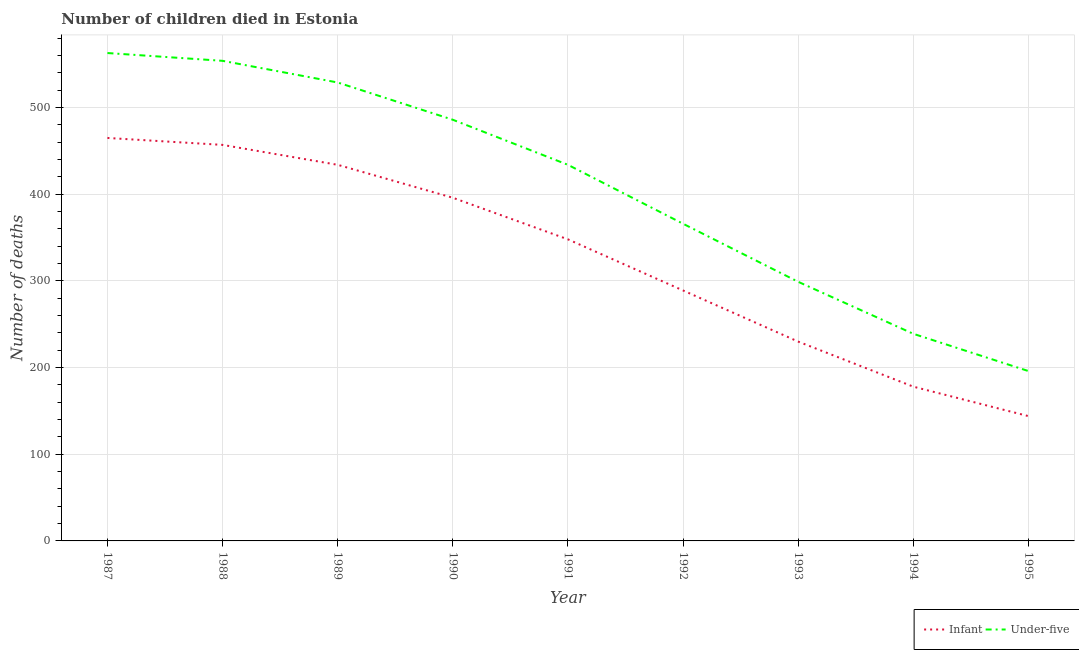Does the line corresponding to number of under-five deaths intersect with the line corresponding to number of infant deaths?
Give a very brief answer. No. What is the number of under-five deaths in 1994?
Provide a short and direct response. 239. Across all years, what is the maximum number of infant deaths?
Provide a succinct answer. 465. Across all years, what is the minimum number of under-five deaths?
Your answer should be compact. 196. In which year was the number of infant deaths minimum?
Provide a succinct answer. 1995. What is the total number of under-five deaths in the graph?
Your response must be concise. 3666. What is the difference between the number of infant deaths in 1990 and that in 1991?
Keep it short and to the point. 48. What is the difference between the number of under-five deaths in 1992 and the number of infant deaths in 1990?
Offer a terse response. -30. What is the average number of infant deaths per year?
Provide a short and direct response. 326.78. In the year 1989, what is the difference between the number of infant deaths and number of under-five deaths?
Your answer should be very brief. -95. In how many years, is the number of infant deaths greater than 200?
Your answer should be compact. 7. What is the ratio of the number of infant deaths in 1993 to that in 1994?
Your answer should be compact. 1.29. Is the number of infant deaths in 1990 less than that in 1991?
Offer a very short reply. No. Is the difference between the number of under-five deaths in 1992 and 1995 greater than the difference between the number of infant deaths in 1992 and 1995?
Ensure brevity in your answer.  Yes. What is the difference between the highest and the second highest number of under-five deaths?
Offer a very short reply. 9. What is the difference between the highest and the lowest number of infant deaths?
Make the answer very short. 321. In how many years, is the number of under-five deaths greater than the average number of under-five deaths taken over all years?
Make the answer very short. 5. Does the number of infant deaths monotonically increase over the years?
Keep it short and to the point. No. How many years are there in the graph?
Your answer should be compact. 9. What is the difference between two consecutive major ticks on the Y-axis?
Make the answer very short. 100. Does the graph contain grids?
Offer a terse response. Yes. Where does the legend appear in the graph?
Your answer should be compact. Bottom right. What is the title of the graph?
Provide a short and direct response. Number of children died in Estonia. What is the label or title of the X-axis?
Ensure brevity in your answer.  Year. What is the label or title of the Y-axis?
Your response must be concise. Number of deaths. What is the Number of deaths of Infant in 1987?
Ensure brevity in your answer.  465. What is the Number of deaths of Under-five in 1987?
Offer a very short reply. 563. What is the Number of deaths of Infant in 1988?
Provide a succinct answer. 457. What is the Number of deaths of Under-five in 1988?
Offer a very short reply. 554. What is the Number of deaths of Infant in 1989?
Give a very brief answer. 434. What is the Number of deaths of Under-five in 1989?
Make the answer very short. 529. What is the Number of deaths of Infant in 1990?
Your answer should be very brief. 396. What is the Number of deaths of Under-five in 1990?
Your response must be concise. 486. What is the Number of deaths of Infant in 1991?
Provide a short and direct response. 348. What is the Number of deaths of Under-five in 1991?
Make the answer very short. 434. What is the Number of deaths of Infant in 1992?
Offer a terse response. 289. What is the Number of deaths in Under-five in 1992?
Your response must be concise. 366. What is the Number of deaths in Infant in 1993?
Provide a short and direct response. 230. What is the Number of deaths of Under-five in 1993?
Your answer should be very brief. 299. What is the Number of deaths in Infant in 1994?
Give a very brief answer. 178. What is the Number of deaths in Under-five in 1994?
Your answer should be compact. 239. What is the Number of deaths of Infant in 1995?
Keep it short and to the point. 144. What is the Number of deaths of Under-five in 1995?
Offer a terse response. 196. Across all years, what is the maximum Number of deaths in Infant?
Your answer should be compact. 465. Across all years, what is the maximum Number of deaths in Under-five?
Provide a succinct answer. 563. Across all years, what is the minimum Number of deaths of Infant?
Provide a short and direct response. 144. Across all years, what is the minimum Number of deaths of Under-five?
Make the answer very short. 196. What is the total Number of deaths of Infant in the graph?
Your response must be concise. 2941. What is the total Number of deaths of Under-five in the graph?
Provide a succinct answer. 3666. What is the difference between the Number of deaths of Under-five in 1987 and that in 1988?
Offer a very short reply. 9. What is the difference between the Number of deaths of Under-five in 1987 and that in 1989?
Make the answer very short. 34. What is the difference between the Number of deaths in Under-five in 1987 and that in 1990?
Your answer should be very brief. 77. What is the difference between the Number of deaths of Infant in 1987 and that in 1991?
Keep it short and to the point. 117. What is the difference between the Number of deaths of Under-five in 1987 and that in 1991?
Make the answer very short. 129. What is the difference between the Number of deaths of Infant in 1987 and that in 1992?
Provide a succinct answer. 176. What is the difference between the Number of deaths of Under-five in 1987 and that in 1992?
Your answer should be very brief. 197. What is the difference between the Number of deaths in Infant in 1987 and that in 1993?
Offer a terse response. 235. What is the difference between the Number of deaths of Under-five in 1987 and that in 1993?
Your response must be concise. 264. What is the difference between the Number of deaths of Infant in 1987 and that in 1994?
Keep it short and to the point. 287. What is the difference between the Number of deaths in Under-five in 1987 and that in 1994?
Give a very brief answer. 324. What is the difference between the Number of deaths in Infant in 1987 and that in 1995?
Keep it short and to the point. 321. What is the difference between the Number of deaths of Under-five in 1987 and that in 1995?
Offer a very short reply. 367. What is the difference between the Number of deaths of Infant in 1988 and that in 1989?
Provide a short and direct response. 23. What is the difference between the Number of deaths in Infant in 1988 and that in 1990?
Your answer should be very brief. 61. What is the difference between the Number of deaths of Infant in 1988 and that in 1991?
Provide a short and direct response. 109. What is the difference between the Number of deaths in Under-five in 1988 and that in 1991?
Provide a short and direct response. 120. What is the difference between the Number of deaths in Infant in 1988 and that in 1992?
Make the answer very short. 168. What is the difference between the Number of deaths of Under-five in 1988 and that in 1992?
Make the answer very short. 188. What is the difference between the Number of deaths in Infant in 1988 and that in 1993?
Provide a succinct answer. 227. What is the difference between the Number of deaths of Under-five in 1988 and that in 1993?
Give a very brief answer. 255. What is the difference between the Number of deaths in Infant in 1988 and that in 1994?
Offer a very short reply. 279. What is the difference between the Number of deaths of Under-five in 1988 and that in 1994?
Offer a terse response. 315. What is the difference between the Number of deaths of Infant in 1988 and that in 1995?
Make the answer very short. 313. What is the difference between the Number of deaths of Under-five in 1988 and that in 1995?
Offer a terse response. 358. What is the difference between the Number of deaths of Under-five in 1989 and that in 1991?
Offer a terse response. 95. What is the difference between the Number of deaths of Infant in 1989 and that in 1992?
Offer a terse response. 145. What is the difference between the Number of deaths in Under-five in 1989 and that in 1992?
Keep it short and to the point. 163. What is the difference between the Number of deaths of Infant in 1989 and that in 1993?
Offer a terse response. 204. What is the difference between the Number of deaths of Under-five in 1989 and that in 1993?
Give a very brief answer. 230. What is the difference between the Number of deaths in Infant in 1989 and that in 1994?
Offer a very short reply. 256. What is the difference between the Number of deaths of Under-five in 1989 and that in 1994?
Your answer should be very brief. 290. What is the difference between the Number of deaths in Infant in 1989 and that in 1995?
Give a very brief answer. 290. What is the difference between the Number of deaths in Under-five in 1989 and that in 1995?
Your response must be concise. 333. What is the difference between the Number of deaths of Infant in 1990 and that in 1991?
Offer a terse response. 48. What is the difference between the Number of deaths in Infant in 1990 and that in 1992?
Provide a short and direct response. 107. What is the difference between the Number of deaths in Under-five in 1990 and that in 1992?
Offer a very short reply. 120. What is the difference between the Number of deaths of Infant in 1990 and that in 1993?
Offer a terse response. 166. What is the difference between the Number of deaths of Under-five in 1990 and that in 1993?
Your answer should be very brief. 187. What is the difference between the Number of deaths of Infant in 1990 and that in 1994?
Ensure brevity in your answer.  218. What is the difference between the Number of deaths in Under-five in 1990 and that in 1994?
Offer a terse response. 247. What is the difference between the Number of deaths of Infant in 1990 and that in 1995?
Ensure brevity in your answer.  252. What is the difference between the Number of deaths in Under-five in 1990 and that in 1995?
Provide a succinct answer. 290. What is the difference between the Number of deaths of Infant in 1991 and that in 1992?
Your response must be concise. 59. What is the difference between the Number of deaths in Infant in 1991 and that in 1993?
Your response must be concise. 118. What is the difference between the Number of deaths of Under-five in 1991 and that in 1993?
Provide a succinct answer. 135. What is the difference between the Number of deaths in Infant in 1991 and that in 1994?
Provide a succinct answer. 170. What is the difference between the Number of deaths in Under-five in 1991 and that in 1994?
Provide a short and direct response. 195. What is the difference between the Number of deaths in Infant in 1991 and that in 1995?
Make the answer very short. 204. What is the difference between the Number of deaths of Under-five in 1991 and that in 1995?
Give a very brief answer. 238. What is the difference between the Number of deaths in Infant in 1992 and that in 1993?
Offer a very short reply. 59. What is the difference between the Number of deaths of Infant in 1992 and that in 1994?
Give a very brief answer. 111. What is the difference between the Number of deaths in Under-five in 1992 and that in 1994?
Provide a succinct answer. 127. What is the difference between the Number of deaths in Infant in 1992 and that in 1995?
Your response must be concise. 145. What is the difference between the Number of deaths of Under-five in 1992 and that in 1995?
Ensure brevity in your answer.  170. What is the difference between the Number of deaths of Under-five in 1993 and that in 1994?
Your answer should be compact. 60. What is the difference between the Number of deaths of Under-five in 1993 and that in 1995?
Your answer should be very brief. 103. What is the difference between the Number of deaths of Infant in 1994 and that in 1995?
Offer a terse response. 34. What is the difference between the Number of deaths in Infant in 1987 and the Number of deaths in Under-five in 1988?
Keep it short and to the point. -89. What is the difference between the Number of deaths in Infant in 1987 and the Number of deaths in Under-five in 1989?
Ensure brevity in your answer.  -64. What is the difference between the Number of deaths of Infant in 1987 and the Number of deaths of Under-five in 1990?
Offer a very short reply. -21. What is the difference between the Number of deaths in Infant in 1987 and the Number of deaths in Under-five in 1991?
Make the answer very short. 31. What is the difference between the Number of deaths of Infant in 1987 and the Number of deaths of Under-five in 1992?
Give a very brief answer. 99. What is the difference between the Number of deaths of Infant in 1987 and the Number of deaths of Under-five in 1993?
Offer a terse response. 166. What is the difference between the Number of deaths in Infant in 1987 and the Number of deaths in Under-five in 1994?
Your answer should be very brief. 226. What is the difference between the Number of deaths in Infant in 1987 and the Number of deaths in Under-five in 1995?
Your answer should be very brief. 269. What is the difference between the Number of deaths in Infant in 1988 and the Number of deaths in Under-five in 1989?
Make the answer very short. -72. What is the difference between the Number of deaths of Infant in 1988 and the Number of deaths of Under-five in 1991?
Your answer should be compact. 23. What is the difference between the Number of deaths in Infant in 1988 and the Number of deaths in Under-five in 1992?
Your response must be concise. 91. What is the difference between the Number of deaths of Infant in 1988 and the Number of deaths of Under-five in 1993?
Provide a succinct answer. 158. What is the difference between the Number of deaths in Infant in 1988 and the Number of deaths in Under-five in 1994?
Make the answer very short. 218. What is the difference between the Number of deaths in Infant in 1988 and the Number of deaths in Under-five in 1995?
Make the answer very short. 261. What is the difference between the Number of deaths of Infant in 1989 and the Number of deaths of Under-five in 1990?
Your answer should be very brief. -52. What is the difference between the Number of deaths in Infant in 1989 and the Number of deaths in Under-five in 1991?
Make the answer very short. 0. What is the difference between the Number of deaths in Infant in 1989 and the Number of deaths in Under-five in 1992?
Ensure brevity in your answer.  68. What is the difference between the Number of deaths in Infant in 1989 and the Number of deaths in Under-five in 1993?
Keep it short and to the point. 135. What is the difference between the Number of deaths of Infant in 1989 and the Number of deaths of Under-five in 1994?
Keep it short and to the point. 195. What is the difference between the Number of deaths of Infant in 1989 and the Number of deaths of Under-five in 1995?
Offer a terse response. 238. What is the difference between the Number of deaths in Infant in 1990 and the Number of deaths in Under-five in 1991?
Your answer should be compact. -38. What is the difference between the Number of deaths in Infant in 1990 and the Number of deaths in Under-five in 1992?
Offer a terse response. 30. What is the difference between the Number of deaths of Infant in 1990 and the Number of deaths of Under-five in 1993?
Provide a succinct answer. 97. What is the difference between the Number of deaths of Infant in 1990 and the Number of deaths of Under-five in 1994?
Make the answer very short. 157. What is the difference between the Number of deaths in Infant in 1991 and the Number of deaths in Under-five in 1993?
Provide a short and direct response. 49. What is the difference between the Number of deaths in Infant in 1991 and the Number of deaths in Under-five in 1994?
Your answer should be compact. 109. What is the difference between the Number of deaths in Infant in 1991 and the Number of deaths in Under-five in 1995?
Ensure brevity in your answer.  152. What is the difference between the Number of deaths in Infant in 1992 and the Number of deaths in Under-five in 1995?
Offer a terse response. 93. What is the difference between the Number of deaths of Infant in 1994 and the Number of deaths of Under-five in 1995?
Give a very brief answer. -18. What is the average Number of deaths in Infant per year?
Your answer should be compact. 326.78. What is the average Number of deaths in Under-five per year?
Keep it short and to the point. 407.33. In the year 1987, what is the difference between the Number of deaths of Infant and Number of deaths of Under-five?
Offer a terse response. -98. In the year 1988, what is the difference between the Number of deaths in Infant and Number of deaths in Under-five?
Keep it short and to the point. -97. In the year 1989, what is the difference between the Number of deaths of Infant and Number of deaths of Under-five?
Your response must be concise. -95. In the year 1990, what is the difference between the Number of deaths in Infant and Number of deaths in Under-five?
Provide a short and direct response. -90. In the year 1991, what is the difference between the Number of deaths in Infant and Number of deaths in Under-five?
Offer a terse response. -86. In the year 1992, what is the difference between the Number of deaths in Infant and Number of deaths in Under-five?
Offer a terse response. -77. In the year 1993, what is the difference between the Number of deaths in Infant and Number of deaths in Under-five?
Keep it short and to the point. -69. In the year 1994, what is the difference between the Number of deaths in Infant and Number of deaths in Under-five?
Offer a very short reply. -61. In the year 1995, what is the difference between the Number of deaths in Infant and Number of deaths in Under-five?
Your answer should be very brief. -52. What is the ratio of the Number of deaths of Infant in 1987 to that in 1988?
Give a very brief answer. 1.02. What is the ratio of the Number of deaths of Under-five in 1987 to that in 1988?
Provide a short and direct response. 1.02. What is the ratio of the Number of deaths of Infant in 1987 to that in 1989?
Your response must be concise. 1.07. What is the ratio of the Number of deaths in Under-five in 1987 to that in 1989?
Give a very brief answer. 1.06. What is the ratio of the Number of deaths of Infant in 1987 to that in 1990?
Make the answer very short. 1.17. What is the ratio of the Number of deaths of Under-five in 1987 to that in 1990?
Offer a very short reply. 1.16. What is the ratio of the Number of deaths of Infant in 1987 to that in 1991?
Keep it short and to the point. 1.34. What is the ratio of the Number of deaths in Under-five in 1987 to that in 1991?
Offer a very short reply. 1.3. What is the ratio of the Number of deaths in Infant in 1987 to that in 1992?
Provide a succinct answer. 1.61. What is the ratio of the Number of deaths in Under-five in 1987 to that in 1992?
Provide a succinct answer. 1.54. What is the ratio of the Number of deaths in Infant in 1987 to that in 1993?
Offer a terse response. 2.02. What is the ratio of the Number of deaths in Under-five in 1987 to that in 1993?
Provide a succinct answer. 1.88. What is the ratio of the Number of deaths in Infant in 1987 to that in 1994?
Offer a terse response. 2.61. What is the ratio of the Number of deaths of Under-five in 1987 to that in 1994?
Offer a very short reply. 2.36. What is the ratio of the Number of deaths in Infant in 1987 to that in 1995?
Ensure brevity in your answer.  3.23. What is the ratio of the Number of deaths in Under-five in 1987 to that in 1995?
Your answer should be very brief. 2.87. What is the ratio of the Number of deaths of Infant in 1988 to that in 1989?
Offer a very short reply. 1.05. What is the ratio of the Number of deaths in Under-five in 1988 to that in 1989?
Keep it short and to the point. 1.05. What is the ratio of the Number of deaths of Infant in 1988 to that in 1990?
Your answer should be compact. 1.15. What is the ratio of the Number of deaths of Under-five in 1988 to that in 1990?
Provide a succinct answer. 1.14. What is the ratio of the Number of deaths of Infant in 1988 to that in 1991?
Offer a very short reply. 1.31. What is the ratio of the Number of deaths of Under-five in 1988 to that in 1991?
Your response must be concise. 1.28. What is the ratio of the Number of deaths of Infant in 1988 to that in 1992?
Keep it short and to the point. 1.58. What is the ratio of the Number of deaths of Under-five in 1988 to that in 1992?
Your answer should be compact. 1.51. What is the ratio of the Number of deaths in Infant in 1988 to that in 1993?
Your response must be concise. 1.99. What is the ratio of the Number of deaths in Under-five in 1988 to that in 1993?
Offer a terse response. 1.85. What is the ratio of the Number of deaths of Infant in 1988 to that in 1994?
Ensure brevity in your answer.  2.57. What is the ratio of the Number of deaths in Under-five in 1988 to that in 1994?
Ensure brevity in your answer.  2.32. What is the ratio of the Number of deaths in Infant in 1988 to that in 1995?
Your answer should be very brief. 3.17. What is the ratio of the Number of deaths in Under-five in 1988 to that in 1995?
Your answer should be compact. 2.83. What is the ratio of the Number of deaths of Infant in 1989 to that in 1990?
Give a very brief answer. 1.1. What is the ratio of the Number of deaths in Under-five in 1989 to that in 1990?
Your response must be concise. 1.09. What is the ratio of the Number of deaths of Infant in 1989 to that in 1991?
Give a very brief answer. 1.25. What is the ratio of the Number of deaths of Under-five in 1989 to that in 1991?
Your response must be concise. 1.22. What is the ratio of the Number of deaths in Infant in 1989 to that in 1992?
Offer a terse response. 1.5. What is the ratio of the Number of deaths of Under-five in 1989 to that in 1992?
Offer a very short reply. 1.45. What is the ratio of the Number of deaths in Infant in 1989 to that in 1993?
Your answer should be compact. 1.89. What is the ratio of the Number of deaths in Under-five in 1989 to that in 1993?
Make the answer very short. 1.77. What is the ratio of the Number of deaths of Infant in 1989 to that in 1994?
Provide a succinct answer. 2.44. What is the ratio of the Number of deaths of Under-five in 1989 to that in 1994?
Ensure brevity in your answer.  2.21. What is the ratio of the Number of deaths of Infant in 1989 to that in 1995?
Keep it short and to the point. 3.01. What is the ratio of the Number of deaths of Under-five in 1989 to that in 1995?
Your response must be concise. 2.7. What is the ratio of the Number of deaths in Infant in 1990 to that in 1991?
Keep it short and to the point. 1.14. What is the ratio of the Number of deaths in Under-five in 1990 to that in 1991?
Give a very brief answer. 1.12. What is the ratio of the Number of deaths in Infant in 1990 to that in 1992?
Your response must be concise. 1.37. What is the ratio of the Number of deaths of Under-five in 1990 to that in 1992?
Provide a succinct answer. 1.33. What is the ratio of the Number of deaths of Infant in 1990 to that in 1993?
Offer a terse response. 1.72. What is the ratio of the Number of deaths of Under-five in 1990 to that in 1993?
Provide a short and direct response. 1.63. What is the ratio of the Number of deaths of Infant in 1990 to that in 1994?
Provide a short and direct response. 2.22. What is the ratio of the Number of deaths of Under-five in 1990 to that in 1994?
Offer a very short reply. 2.03. What is the ratio of the Number of deaths of Infant in 1990 to that in 1995?
Offer a terse response. 2.75. What is the ratio of the Number of deaths of Under-five in 1990 to that in 1995?
Provide a short and direct response. 2.48. What is the ratio of the Number of deaths of Infant in 1991 to that in 1992?
Make the answer very short. 1.2. What is the ratio of the Number of deaths in Under-five in 1991 to that in 1992?
Give a very brief answer. 1.19. What is the ratio of the Number of deaths in Infant in 1991 to that in 1993?
Provide a succinct answer. 1.51. What is the ratio of the Number of deaths in Under-five in 1991 to that in 1993?
Your response must be concise. 1.45. What is the ratio of the Number of deaths in Infant in 1991 to that in 1994?
Your answer should be very brief. 1.96. What is the ratio of the Number of deaths of Under-five in 1991 to that in 1994?
Offer a very short reply. 1.82. What is the ratio of the Number of deaths in Infant in 1991 to that in 1995?
Provide a succinct answer. 2.42. What is the ratio of the Number of deaths in Under-five in 1991 to that in 1995?
Offer a terse response. 2.21. What is the ratio of the Number of deaths in Infant in 1992 to that in 1993?
Your answer should be compact. 1.26. What is the ratio of the Number of deaths of Under-five in 1992 to that in 1993?
Make the answer very short. 1.22. What is the ratio of the Number of deaths in Infant in 1992 to that in 1994?
Your answer should be compact. 1.62. What is the ratio of the Number of deaths in Under-five in 1992 to that in 1994?
Your answer should be very brief. 1.53. What is the ratio of the Number of deaths of Infant in 1992 to that in 1995?
Ensure brevity in your answer.  2.01. What is the ratio of the Number of deaths in Under-five in 1992 to that in 1995?
Your answer should be compact. 1.87. What is the ratio of the Number of deaths of Infant in 1993 to that in 1994?
Your response must be concise. 1.29. What is the ratio of the Number of deaths of Under-five in 1993 to that in 1994?
Provide a short and direct response. 1.25. What is the ratio of the Number of deaths in Infant in 1993 to that in 1995?
Provide a succinct answer. 1.6. What is the ratio of the Number of deaths in Under-five in 1993 to that in 1995?
Offer a very short reply. 1.53. What is the ratio of the Number of deaths in Infant in 1994 to that in 1995?
Your answer should be compact. 1.24. What is the ratio of the Number of deaths in Under-five in 1994 to that in 1995?
Offer a very short reply. 1.22. What is the difference between the highest and the second highest Number of deaths of Infant?
Offer a terse response. 8. What is the difference between the highest and the lowest Number of deaths in Infant?
Ensure brevity in your answer.  321. What is the difference between the highest and the lowest Number of deaths of Under-five?
Make the answer very short. 367. 